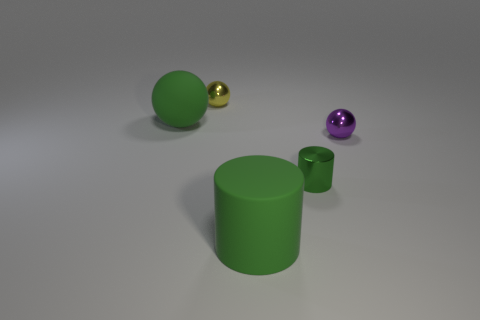Add 1 big green matte objects. How many objects exist? 6 Subtract all cylinders. How many objects are left? 3 Add 5 large rubber balls. How many large rubber balls exist? 6 Subtract 1 green balls. How many objects are left? 4 Subtract all purple objects. Subtract all metal cylinders. How many objects are left? 3 Add 3 yellow shiny objects. How many yellow shiny objects are left? 4 